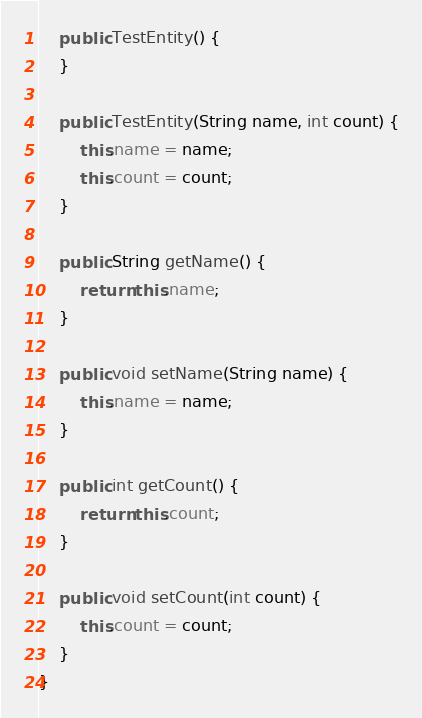Convert code to text. <code><loc_0><loc_0><loc_500><loc_500><_Java_>

	public TestEntity() {
	}

	public TestEntity(String name, int count) {
		this.name = name;
		this.count = count;
	}

	public String getName() {
		return this.name;
	}

	public void setName(String name) {
		this.name = name;
	}

	public int getCount() {
		return this.count;
	}

	public void setCount(int count) {
		this.count = count;
	}
}
</code> 